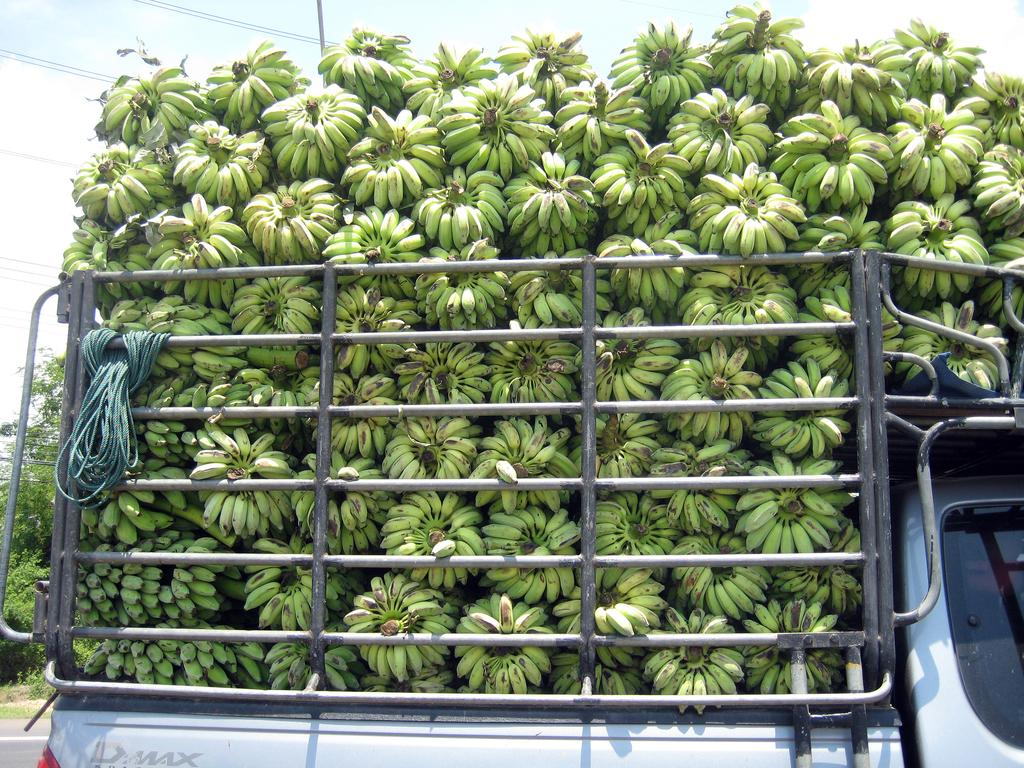What is the color of the bananas on the vehicle in the image? The bananas on the vehicle are green. What is used to secure the vehicle in the image? Ropes are tied to the vehicle. What can be seen in the background of the image? There are wires and trees visible in the background. What is visible above the trees in the image? The sky is visible in the background. Where is the mother in the image? There is no mother present in the image. What type of cart is being used to transport the bananas in the image? The image does not show a cart; it shows a vehicle with bananas on it. 